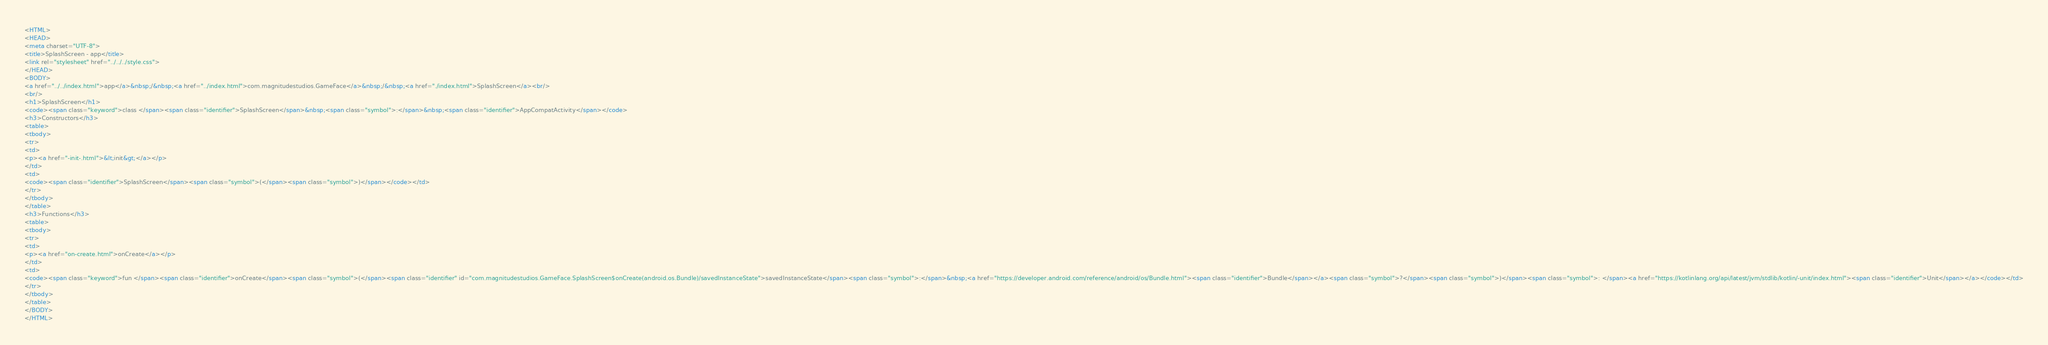<code> <loc_0><loc_0><loc_500><loc_500><_HTML_><HTML>
<HEAD>
<meta charset="UTF-8">
<title>SplashScreen - app</title>
<link rel="stylesheet" href="../../../style.css">
</HEAD>
<BODY>
<a href="../../index.html">app</a>&nbsp;/&nbsp;<a href="../index.html">com.magnitudestudios.GameFace</a>&nbsp;/&nbsp;<a href="./index.html">SplashScreen</a><br/>
<br/>
<h1>SplashScreen</h1>
<code><span class="keyword">class </span><span class="identifier">SplashScreen</span>&nbsp;<span class="symbol">:</span>&nbsp;<span class="identifier">AppCompatActivity</span></code>
<h3>Constructors</h3>
<table>
<tbody>
<tr>
<td>
<p><a href="-init-.html">&lt;init&gt;</a></p>
</td>
<td>
<code><span class="identifier">SplashScreen</span><span class="symbol">(</span><span class="symbol">)</span></code></td>
</tr>
</tbody>
</table>
<h3>Functions</h3>
<table>
<tbody>
<tr>
<td>
<p><a href="on-create.html">onCreate</a></p>
</td>
<td>
<code><span class="keyword">fun </span><span class="identifier">onCreate</span><span class="symbol">(</span><span class="identifier" id="com.magnitudestudios.GameFace.SplashScreen$onCreate(android.os.Bundle)/savedInstanceState">savedInstanceState</span><span class="symbol">:</span>&nbsp;<a href="https://developer.android.com/reference/android/os/Bundle.html"><span class="identifier">Bundle</span></a><span class="symbol">?</span><span class="symbol">)</span><span class="symbol">: </span><a href="https://kotlinlang.org/api/latest/jvm/stdlib/kotlin/-unit/index.html"><span class="identifier">Unit</span></a></code></td>
</tr>
</tbody>
</table>
</BODY>
</HTML>
</code> 